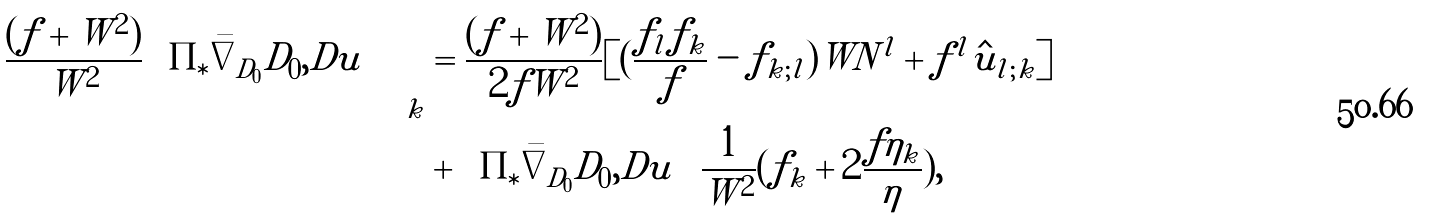Convert formula to latex. <formula><loc_0><loc_0><loc_500><loc_500>\left ( \frac { ( f + W ^ { 2 } ) } { W ^ { 2 } } \left \langle \Pi _ { \ast } \bar { \nabla } _ { D _ { 0 } } D _ { 0 } , D u \right \rangle \right ) _ { k } & = \frac { ( f + W ^ { 2 } ) } { 2 f W ^ { 2 } } [ ( \frac { f _ { l } f _ { k } } { f } - f _ { k ; l } ) W N ^ { l } + f ^ { l } \hat { u } _ { l ; k } ] \\ & + \left \langle \Pi _ { \ast } \bar { \nabla } _ { D _ { 0 } } D _ { 0 } , D u \right \rangle \frac { 1 } { W ^ { 2 } } ( f _ { k } + 2 \frac { f \eta _ { k } } { \eta } ) ,</formula> 